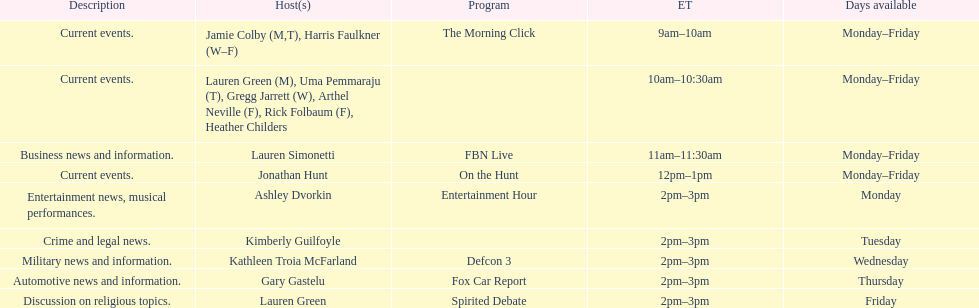Tell me the number of shows that only have one host per day. 7. Parse the full table. {'header': ['Description', 'Host(s)', 'Program', 'ET', 'Days available'], 'rows': [['Current events.', 'Jamie Colby (M,T), Harris Faulkner (W–F)', 'The Morning Click', '9am–10am', 'Monday–Friday'], ['Current events.', 'Lauren Green (M), Uma Pemmaraju (T), Gregg Jarrett (W), Arthel Neville (F), Rick Folbaum (F), Heather Childers', '', '10am–10:30am', 'Monday–Friday'], ['Business news and information.', 'Lauren Simonetti', 'FBN Live', '11am–11:30am', 'Monday–Friday'], ['Current events.', 'Jonathan Hunt', 'On the Hunt', '12pm–1pm', 'Monday–Friday'], ['Entertainment news, musical performances.', 'Ashley Dvorkin', 'Entertainment Hour', '2pm–3pm', 'Monday'], ['Crime and legal news.', 'Kimberly Guilfoyle', '', '2pm–3pm', 'Tuesday'], ['Military news and information.', 'Kathleen Troia McFarland', 'Defcon 3', '2pm–3pm', 'Wednesday'], ['Automotive news and information.', 'Gary Gastelu', 'Fox Car Report', '2pm–3pm', 'Thursday'], ['Discussion on religious topics.', 'Lauren Green', 'Spirited Debate', '2pm–3pm', 'Friday']]} 